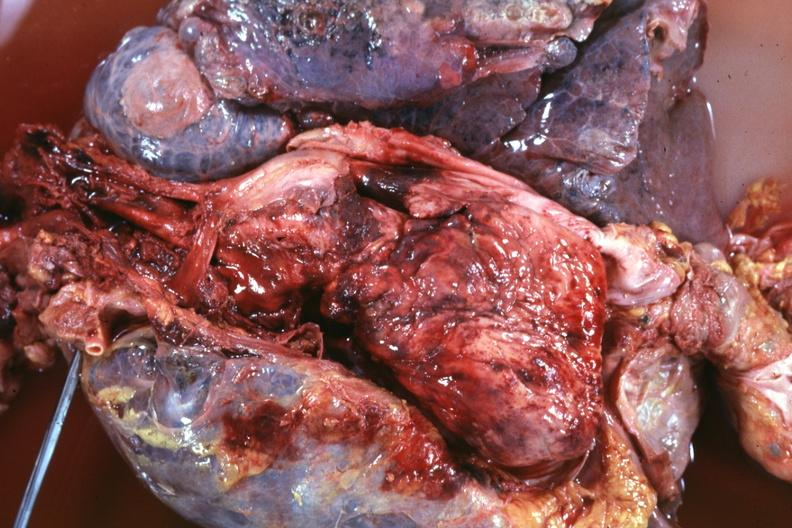how is thoracic organs dissected to show cava and region of tumor invasion quite good?
Answer the question using a single word or phrase. Super 